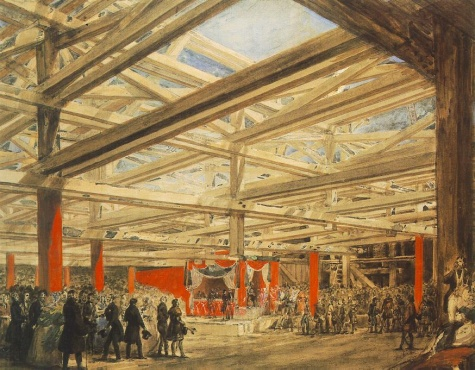What do you see happening in this image? This painting vividly depicts a bustling scene inside a grand hall, characterized by a high wooden beam ceiling and an atmosphere filled with activity. Numerous people populate the hall, some engaged in animated conversations while others observe their surroundings or rest. The stage, highlighted by eye-catching red curtains, hosts a prominent throne, indicating an event of significance, perhaps awaiting a royal presence or a ceremonial occasion. The realistic style and meticulous details, from the textures of the wooden beams to the expressions and attire of the figures, suggest the painting might be a historical or genre piece from the 19th century, offering a rich glimpse into the social dynamics and architectural styles of the period. 